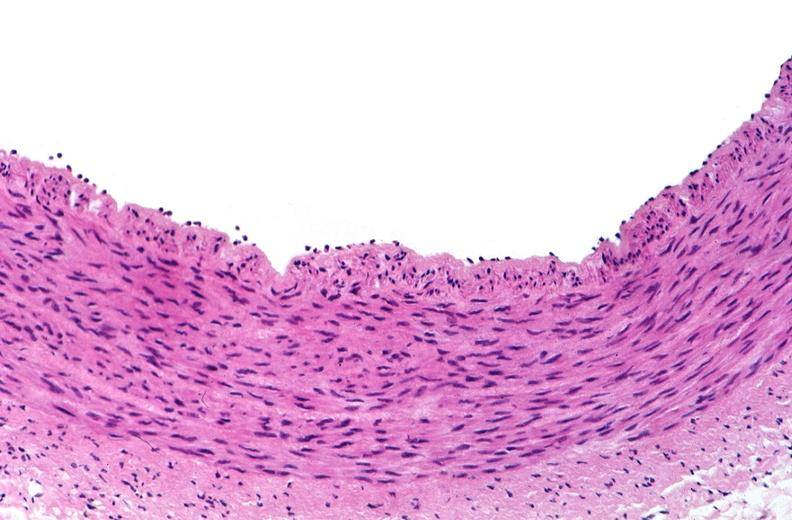what does this image show?
Answer the question using a single word or phrase. Acute inflammation 